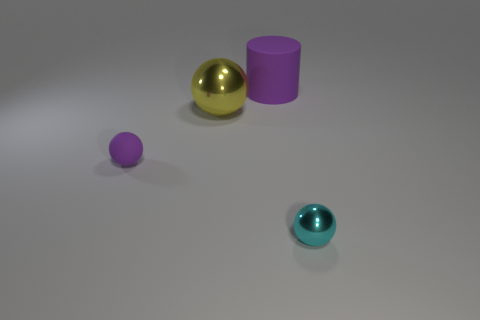What number of other objects are the same size as the rubber ball?
Give a very brief answer. 1. There is a purple rubber object that is the same shape as the small metal object; what size is it?
Make the answer very short. Small. The purple matte thing that is behind the big yellow sphere has what shape?
Offer a terse response. Cylinder. What color is the big thing behind the metallic sphere that is behind the cyan metallic thing?
Your response must be concise. Purple. What number of objects are purple objects right of the yellow metal object or purple matte balls?
Ensure brevity in your answer.  2. Does the yellow metallic ball have the same size as the rubber object that is on the right side of the small rubber sphere?
Make the answer very short. Yes. What number of small things are either yellow balls or cylinders?
Provide a succinct answer. 0. What shape is the big purple matte thing?
Ensure brevity in your answer.  Cylinder. There is a cylinder that is the same color as the tiny matte thing; what size is it?
Your answer should be compact. Large. Is there a large red thing that has the same material as the big purple thing?
Offer a terse response. No. 